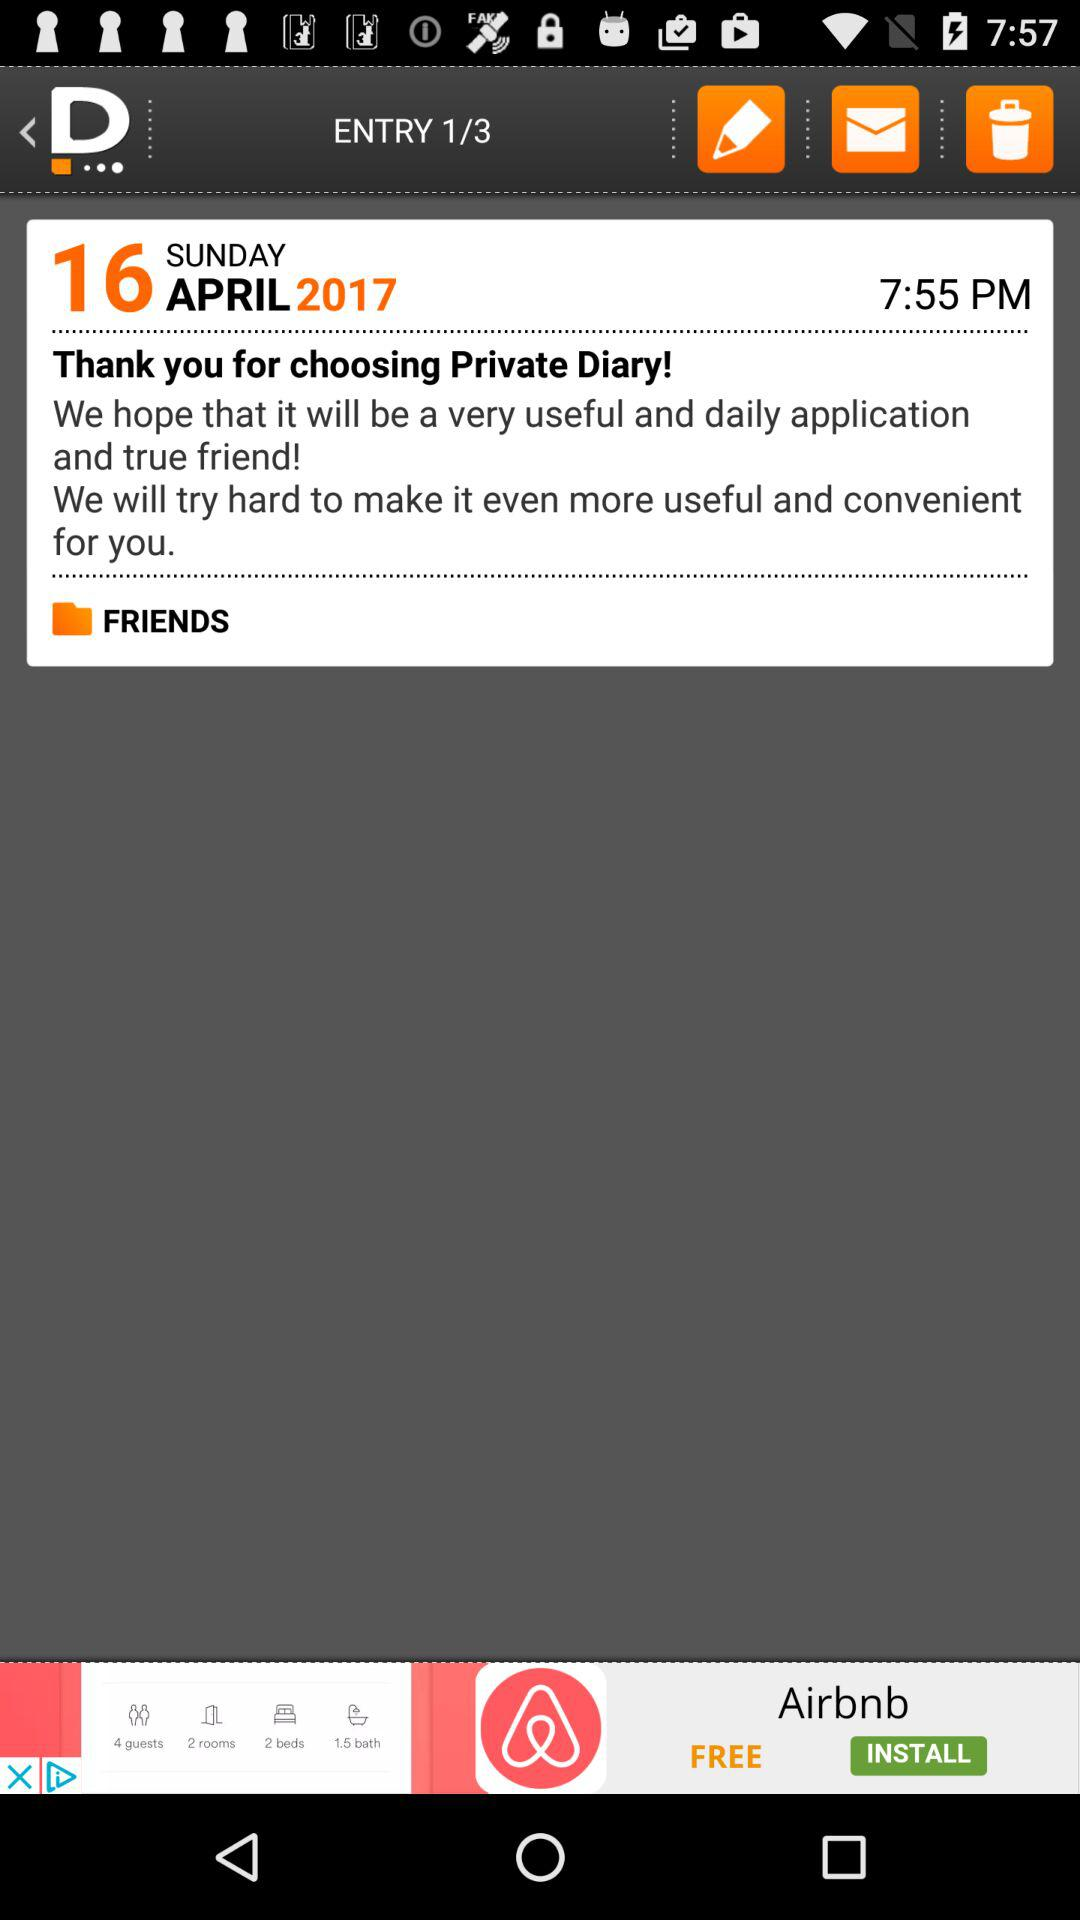What is the displayed date? The displayed date is Sunday, April 16, 2017. 